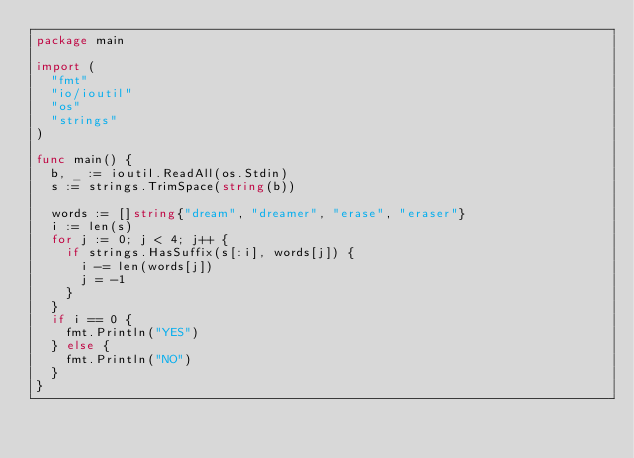<code> <loc_0><loc_0><loc_500><loc_500><_Go_>package main

import (
	"fmt"
	"io/ioutil"
	"os"
	"strings"
)

func main() {
	b, _ := ioutil.ReadAll(os.Stdin)
	s := strings.TrimSpace(string(b))

	words := []string{"dream", "dreamer", "erase", "eraser"}
	i := len(s)
	for j := 0; j < 4; j++ {
		if strings.HasSuffix(s[:i], words[j]) {
			i -= len(words[j])
			j = -1
		}
	}
	if i == 0 {
		fmt.Println("YES")
	} else {
		fmt.Println("NO")
	}
}
</code> 